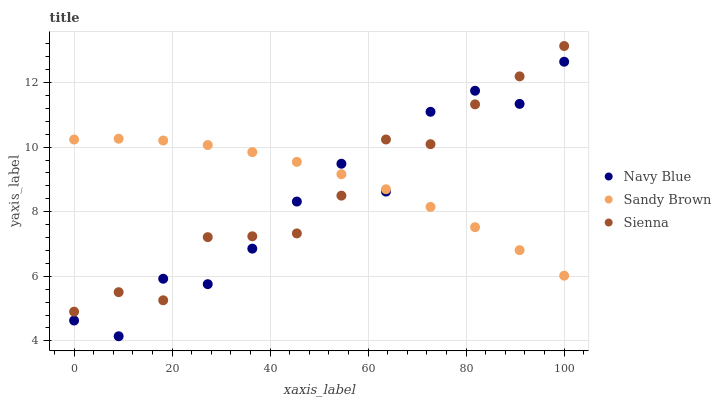Does Navy Blue have the minimum area under the curve?
Answer yes or no. Yes. Does Sandy Brown have the maximum area under the curve?
Answer yes or no. Yes. Does Sandy Brown have the minimum area under the curve?
Answer yes or no. No. Does Navy Blue have the maximum area under the curve?
Answer yes or no. No. Is Sandy Brown the smoothest?
Answer yes or no. Yes. Is Navy Blue the roughest?
Answer yes or no. Yes. Is Navy Blue the smoothest?
Answer yes or no. No. Is Sandy Brown the roughest?
Answer yes or no. No. Does Navy Blue have the lowest value?
Answer yes or no. Yes. Does Sandy Brown have the lowest value?
Answer yes or no. No. Does Sienna have the highest value?
Answer yes or no. Yes. Does Navy Blue have the highest value?
Answer yes or no. No. Does Sienna intersect Navy Blue?
Answer yes or no. Yes. Is Sienna less than Navy Blue?
Answer yes or no. No. Is Sienna greater than Navy Blue?
Answer yes or no. No. 